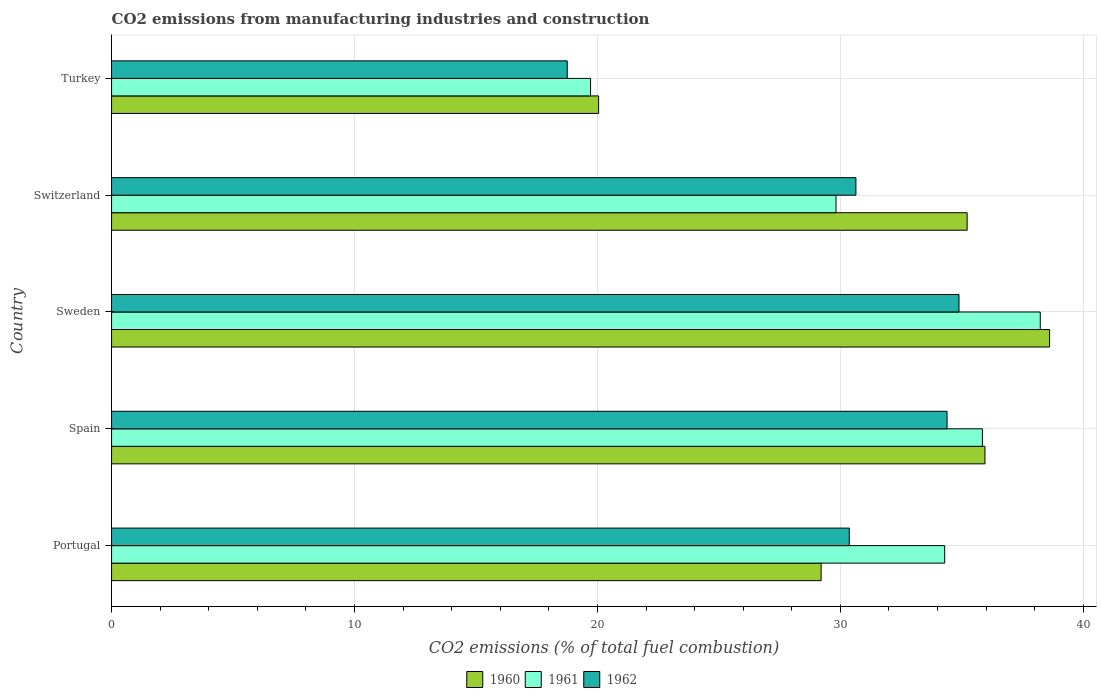Are the number of bars per tick equal to the number of legend labels?
Your answer should be very brief. Yes. Are the number of bars on each tick of the Y-axis equal?
Provide a succinct answer. Yes. In how many cases, is the number of bars for a given country not equal to the number of legend labels?
Ensure brevity in your answer.  0. What is the amount of CO2 emitted in 1960 in Spain?
Ensure brevity in your answer.  35.95. Across all countries, what is the maximum amount of CO2 emitted in 1960?
Keep it short and to the point. 38.61. Across all countries, what is the minimum amount of CO2 emitted in 1962?
Give a very brief answer. 18.76. In which country was the amount of CO2 emitted in 1962 minimum?
Ensure brevity in your answer.  Turkey. What is the total amount of CO2 emitted in 1961 in the graph?
Give a very brief answer. 157.91. What is the difference between the amount of CO2 emitted in 1961 in Portugal and that in Sweden?
Provide a succinct answer. -3.93. What is the difference between the amount of CO2 emitted in 1961 in Switzerland and the amount of CO2 emitted in 1962 in Portugal?
Make the answer very short. -0.55. What is the average amount of CO2 emitted in 1962 per country?
Ensure brevity in your answer.  29.81. What is the difference between the amount of CO2 emitted in 1960 and amount of CO2 emitted in 1961 in Sweden?
Keep it short and to the point. 0.38. What is the ratio of the amount of CO2 emitted in 1961 in Portugal to that in Spain?
Offer a very short reply. 0.96. Is the amount of CO2 emitted in 1960 in Sweden less than that in Switzerland?
Keep it short and to the point. No. Is the difference between the amount of CO2 emitted in 1960 in Spain and Turkey greater than the difference between the amount of CO2 emitted in 1961 in Spain and Turkey?
Give a very brief answer. No. What is the difference between the highest and the second highest amount of CO2 emitted in 1961?
Provide a succinct answer. 2.38. What is the difference between the highest and the lowest amount of CO2 emitted in 1962?
Offer a very short reply. 16.13. In how many countries, is the amount of CO2 emitted in 1962 greater than the average amount of CO2 emitted in 1962 taken over all countries?
Your answer should be very brief. 4. Is the sum of the amount of CO2 emitted in 1961 in Spain and Sweden greater than the maximum amount of CO2 emitted in 1962 across all countries?
Make the answer very short. Yes. What does the 2nd bar from the top in Switzerland represents?
Keep it short and to the point. 1961. Is it the case that in every country, the sum of the amount of CO2 emitted in 1961 and amount of CO2 emitted in 1960 is greater than the amount of CO2 emitted in 1962?
Offer a terse response. Yes. How many bars are there?
Provide a succinct answer. 15. Are all the bars in the graph horizontal?
Offer a very short reply. Yes. Does the graph contain any zero values?
Give a very brief answer. No. Does the graph contain grids?
Your response must be concise. Yes. How many legend labels are there?
Give a very brief answer. 3. What is the title of the graph?
Provide a succinct answer. CO2 emissions from manufacturing industries and construction. Does "2002" appear as one of the legend labels in the graph?
Your answer should be compact. No. What is the label or title of the X-axis?
Give a very brief answer. CO2 emissions (% of total fuel combustion). What is the CO2 emissions (% of total fuel combustion) in 1960 in Portugal?
Your answer should be compact. 29.21. What is the CO2 emissions (% of total fuel combustion) in 1961 in Portugal?
Give a very brief answer. 34.29. What is the CO2 emissions (% of total fuel combustion) in 1962 in Portugal?
Your answer should be compact. 30.37. What is the CO2 emissions (% of total fuel combustion) in 1960 in Spain?
Ensure brevity in your answer.  35.95. What is the CO2 emissions (% of total fuel combustion) of 1961 in Spain?
Your answer should be compact. 35.85. What is the CO2 emissions (% of total fuel combustion) in 1962 in Spain?
Give a very brief answer. 34.39. What is the CO2 emissions (% of total fuel combustion) of 1960 in Sweden?
Your answer should be very brief. 38.61. What is the CO2 emissions (% of total fuel combustion) in 1961 in Sweden?
Keep it short and to the point. 38.23. What is the CO2 emissions (% of total fuel combustion) of 1962 in Sweden?
Provide a short and direct response. 34.88. What is the CO2 emissions (% of total fuel combustion) of 1960 in Switzerland?
Your answer should be very brief. 35.22. What is the CO2 emissions (% of total fuel combustion) in 1961 in Switzerland?
Provide a short and direct response. 29.82. What is the CO2 emissions (% of total fuel combustion) in 1962 in Switzerland?
Provide a succinct answer. 30.64. What is the CO2 emissions (% of total fuel combustion) of 1960 in Turkey?
Ensure brevity in your answer.  20.05. What is the CO2 emissions (% of total fuel combustion) of 1961 in Turkey?
Your response must be concise. 19.72. What is the CO2 emissions (% of total fuel combustion) in 1962 in Turkey?
Your answer should be very brief. 18.76. Across all countries, what is the maximum CO2 emissions (% of total fuel combustion) of 1960?
Provide a short and direct response. 38.61. Across all countries, what is the maximum CO2 emissions (% of total fuel combustion) in 1961?
Make the answer very short. 38.23. Across all countries, what is the maximum CO2 emissions (% of total fuel combustion) in 1962?
Offer a very short reply. 34.88. Across all countries, what is the minimum CO2 emissions (% of total fuel combustion) in 1960?
Your response must be concise. 20.05. Across all countries, what is the minimum CO2 emissions (% of total fuel combustion) of 1961?
Offer a terse response. 19.72. Across all countries, what is the minimum CO2 emissions (% of total fuel combustion) in 1962?
Your answer should be compact. 18.76. What is the total CO2 emissions (% of total fuel combustion) in 1960 in the graph?
Provide a short and direct response. 159.04. What is the total CO2 emissions (% of total fuel combustion) in 1961 in the graph?
Make the answer very short. 157.91. What is the total CO2 emissions (% of total fuel combustion) of 1962 in the graph?
Your answer should be very brief. 149.04. What is the difference between the CO2 emissions (% of total fuel combustion) of 1960 in Portugal and that in Spain?
Your response must be concise. -6.74. What is the difference between the CO2 emissions (% of total fuel combustion) in 1961 in Portugal and that in Spain?
Ensure brevity in your answer.  -1.55. What is the difference between the CO2 emissions (% of total fuel combustion) of 1962 in Portugal and that in Spain?
Give a very brief answer. -4.03. What is the difference between the CO2 emissions (% of total fuel combustion) in 1960 in Portugal and that in Sweden?
Give a very brief answer. -9.4. What is the difference between the CO2 emissions (% of total fuel combustion) of 1961 in Portugal and that in Sweden?
Provide a succinct answer. -3.93. What is the difference between the CO2 emissions (% of total fuel combustion) of 1962 in Portugal and that in Sweden?
Provide a succinct answer. -4.52. What is the difference between the CO2 emissions (% of total fuel combustion) of 1960 in Portugal and that in Switzerland?
Provide a short and direct response. -6.01. What is the difference between the CO2 emissions (% of total fuel combustion) in 1961 in Portugal and that in Switzerland?
Your answer should be compact. 4.47. What is the difference between the CO2 emissions (% of total fuel combustion) of 1962 in Portugal and that in Switzerland?
Your response must be concise. -0.27. What is the difference between the CO2 emissions (% of total fuel combustion) in 1960 in Portugal and that in Turkey?
Give a very brief answer. 9.16. What is the difference between the CO2 emissions (% of total fuel combustion) of 1961 in Portugal and that in Turkey?
Offer a terse response. 14.58. What is the difference between the CO2 emissions (% of total fuel combustion) of 1962 in Portugal and that in Turkey?
Give a very brief answer. 11.61. What is the difference between the CO2 emissions (% of total fuel combustion) in 1960 in Spain and that in Sweden?
Ensure brevity in your answer.  -2.66. What is the difference between the CO2 emissions (% of total fuel combustion) in 1961 in Spain and that in Sweden?
Give a very brief answer. -2.38. What is the difference between the CO2 emissions (% of total fuel combustion) in 1962 in Spain and that in Sweden?
Offer a very short reply. -0.49. What is the difference between the CO2 emissions (% of total fuel combustion) of 1960 in Spain and that in Switzerland?
Offer a very short reply. 0.73. What is the difference between the CO2 emissions (% of total fuel combustion) in 1961 in Spain and that in Switzerland?
Your answer should be very brief. 6.03. What is the difference between the CO2 emissions (% of total fuel combustion) in 1962 in Spain and that in Switzerland?
Give a very brief answer. 3.75. What is the difference between the CO2 emissions (% of total fuel combustion) of 1960 in Spain and that in Turkey?
Your answer should be compact. 15.9. What is the difference between the CO2 emissions (% of total fuel combustion) in 1961 in Spain and that in Turkey?
Keep it short and to the point. 16.13. What is the difference between the CO2 emissions (% of total fuel combustion) of 1962 in Spain and that in Turkey?
Your response must be concise. 15.64. What is the difference between the CO2 emissions (% of total fuel combustion) in 1960 in Sweden and that in Switzerland?
Make the answer very short. 3.39. What is the difference between the CO2 emissions (% of total fuel combustion) in 1961 in Sweden and that in Switzerland?
Make the answer very short. 8.41. What is the difference between the CO2 emissions (% of total fuel combustion) of 1962 in Sweden and that in Switzerland?
Offer a very short reply. 4.24. What is the difference between the CO2 emissions (% of total fuel combustion) of 1960 in Sweden and that in Turkey?
Your response must be concise. 18.56. What is the difference between the CO2 emissions (% of total fuel combustion) in 1961 in Sweden and that in Turkey?
Ensure brevity in your answer.  18.51. What is the difference between the CO2 emissions (% of total fuel combustion) of 1962 in Sweden and that in Turkey?
Provide a short and direct response. 16.13. What is the difference between the CO2 emissions (% of total fuel combustion) in 1960 in Switzerland and that in Turkey?
Provide a succinct answer. 15.17. What is the difference between the CO2 emissions (% of total fuel combustion) in 1961 in Switzerland and that in Turkey?
Keep it short and to the point. 10.1. What is the difference between the CO2 emissions (% of total fuel combustion) in 1962 in Switzerland and that in Turkey?
Your answer should be very brief. 11.88. What is the difference between the CO2 emissions (% of total fuel combustion) of 1960 in Portugal and the CO2 emissions (% of total fuel combustion) of 1961 in Spain?
Offer a very short reply. -6.64. What is the difference between the CO2 emissions (% of total fuel combustion) in 1960 in Portugal and the CO2 emissions (% of total fuel combustion) in 1962 in Spain?
Keep it short and to the point. -5.18. What is the difference between the CO2 emissions (% of total fuel combustion) of 1961 in Portugal and the CO2 emissions (% of total fuel combustion) of 1962 in Spain?
Offer a very short reply. -0.1. What is the difference between the CO2 emissions (% of total fuel combustion) of 1960 in Portugal and the CO2 emissions (% of total fuel combustion) of 1961 in Sweden?
Provide a short and direct response. -9.02. What is the difference between the CO2 emissions (% of total fuel combustion) of 1960 in Portugal and the CO2 emissions (% of total fuel combustion) of 1962 in Sweden?
Provide a short and direct response. -5.68. What is the difference between the CO2 emissions (% of total fuel combustion) of 1961 in Portugal and the CO2 emissions (% of total fuel combustion) of 1962 in Sweden?
Provide a short and direct response. -0.59. What is the difference between the CO2 emissions (% of total fuel combustion) in 1960 in Portugal and the CO2 emissions (% of total fuel combustion) in 1961 in Switzerland?
Your response must be concise. -0.61. What is the difference between the CO2 emissions (% of total fuel combustion) in 1960 in Portugal and the CO2 emissions (% of total fuel combustion) in 1962 in Switzerland?
Make the answer very short. -1.43. What is the difference between the CO2 emissions (% of total fuel combustion) of 1961 in Portugal and the CO2 emissions (% of total fuel combustion) of 1962 in Switzerland?
Ensure brevity in your answer.  3.65. What is the difference between the CO2 emissions (% of total fuel combustion) of 1960 in Portugal and the CO2 emissions (% of total fuel combustion) of 1961 in Turkey?
Ensure brevity in your answer.  9.49. What is the difference between the CO2 emissions (% of total fuel combustion) in 1960 in Portugal and the CO2 emissions (% of total fuel combustion) in 1962 in Turkey?
Offer a terse response. 10.45. What is the difference between the CO2 emissions (% of total fuel combustion) in 1961 in Portugal and the CO2 emissions (% of total fuel combustion) in 1962 in Turkey?
Keep it short and to the point. 15.54. What is the difference between the CO2 emissions (% of total fuel combustion) of 1960 in Spain and the CO2 emissions (% of total fuel combustion) of 1961 in Sweden?
Provide a short and direct response. -2.28. What is the difference between the CO2 emissions (% of total fuel combustion) of 1960 in Spain and the CO2 emissions (% of total fuel combustion) of 1962 in Sweden?
Your response must be concise. 1.07. What is the difference between the CO2 emissions (% of total fuel combustion) of 1961 in Spain and the CO2 emissions (% of total fuel combustion) of 1962 in Sweden?
Your answer should be very brief. 0.96. What is the difference between the CO2 emissions (% of total fuel combustion) in 1960 in Spain and the CO2 emissions (% of total fuel combustion) in 1961 in Switzerland?
Keep it short and to the point. 6.13. What is the difference between the CO2 emissions (% of total fuel combustion) in 1960 in Spain and the CO2 emissions (% of total fuel combustion) in 1962 in Switzerland?
Offer a terse response. 5.31. What is the difference between the CO2 emissions (% of total fuel combustion) of 1961 in Spain and the CO2 emissions (% of total fuel combustion) of 1962 in Switzerland?
Offer a terse response. 5.21. What is the difference between the CO2 emissions (% of total fuel combustion) of 1960 in Spain and the CO2 emissions (% of total fuel combustion) of 1961 in Turkey?
Make the answer very short. 16.24. What is the difference between the CO2 emissions (% of total fuel combustion) in 1960 in Spain and the CO2 emissions (% of total fuel combustion) in 1962 in Turkey?
Provide a succinct answer. 17.2. What is the difference between the CO2 emissions (% of total fuel combustion) of 1961 in Spain and the CO2 emissions (% of total fuel combustion) of 1962 in Turkey?
Keep it short and to the point. 17.09. What is the difference between the CO2 emissions (% of total fuel combustion) in 1960 in Sweden and the CO2 emissions (% of total fuel combustion) in 1961 in Switzerland?
Offer a very short reply. 8.79. What is the difference between the CO2 emissions (% of total fuel combustion) of 1960 in Sweden and the CO2 emissions (% of total fuel combustion) of 1962 in Switzerland?
Your answer should be compact. 7.97. What is the difference between the CO2 emissions (% of total fuel combustion) of 1961 in Sweden and the CO2 emissions (% of total fuel combustion) of 1962 in Switzerland?
Offer a very short reply. 7.59. What is the difference between the CO2 emissions (% of total fuel combustion) in 1960 in Sweden and the CO2 emissions (% of total fuel combustion) in 1961 in Turkey?
Provide a succinct answer. 18.9. What is the difference between the CO2 emissions (% of total fuel combustion) of 1960 in Sweden and the CO2 emissions (% of total fuel combustion) of 1962 in Turkey?
Offer a very short reply. 19.86. What is the difference between the CO2 emissions (% of total fuel combustion) in 1961 in Sweden and the CO2 emissions (% of total fuel combustion) in 1962 in Turkey?
Provide a succinct answer. 19.47. What is the difference between the CO2 emissions (% of total fuel combustion) of 1960 in Switzerland and the CO2 emissions (% of total fuel combustion) of 1961 in Turkey?
Your answer should be very brief. 15.5. What is the difference between the CO2 emissions (% of total fuel combustion) of 1960 in Switzerland and the CO2 emissions (% of total fuel combustion) of 1962 in Turkey?
Offer a terse response. 16.46. What is the difference between the CO2 emissions (% of total fuel combustion) in 1961 in Switzerland and the CO2 emissions (% of total fuel combustion) in 1962 in Turkey?
Provide a short and direct response. 11.06. What is the average CO2 emissions (% of total fuel combustion) of 1960 per country?
Offer a very short reply. 31.81. What is the average CO2 emissions (% of total fuel combustion) of 1961 per country?
Your response must be concise. 31.58. What is the average CO2 emissions (% of total fuel combustion) in 1962 per country?
Your answer should be very brief. 29.81. What is the difference between the CO2 emissions (% of total fuel combustion) of 1960 and CO2 emissions (% of total fuel combustion) of 1961 in Portugal?
Offer a terse response. -5.09. What is the difference between the CO2 emissions (% of total fuel combustion) of 1960 and CO2 emissions (% of total fuel combustion) of 1962 in Portugal?
Your answer should be compact. -1.16. What is the difference between the CO2 emissions (% of total fuel combustion) of 1961 and CO2 emissions (% of total fuel combustion) of 1962 in Portugal?
Your answer should be very brief. 3.93. What is the difference between the CO2 emissions (% of total fuel combustion) in 1960 and CO2 emissions (% of total fuel combustion) in 1961 in Spain?
Your response must be concise. 0.1. What is the difference between the CO2 emissions (% of total fuel combustion) of 1960 and CO2 emissions (% of total fuel combustion) of 1962 in Spain?
Offer a terse response. 1.56. What is the difference between the CO2 emissions (% of total fuel combustion) of 1961 and CO2 emissions (% of total fuel combustion) of 1962 in Spain?
Your answer should be very brief. 1.45. What is the difference between the CO2 emissions (% of total fuel combustion) in 1960 and CO2 emissions (% of total fuel combustion) in 1961 in Sweden?
Provide a short and direct response. 0.38. What is the difference between the CO2 emissions (% of total fuel combustion) of 1960 and CO2 emissions (% of total fuel combustion) of 1962 in Sweden?
Offer a very short reply. 3.73. What is the difference between the CO2 emissions (% of total fuel combustion) in 1961 and CO2 emissions (% of total fuel combustion) in 1962 in Sweden?
Ensure brevity in your answer.  3.35. What is the difference between the CO2 emissions (% of total fuel combustion) in 1960 and CO2 emissions (% of total fuel combustion) in 1961 in Switzerland?
Your response must be concise. 5.4. What is the difference between the CO2 emissions (% of total fuel combustion) of 1960 and CO2 emissions (% of total fuel combustion) of 1962 in Switzerland?
Provide a succinct answer. 4.58. What is the difference between the CO2 emissions (% of total fuel combustion) of 1961 and CO2 emissions (% of total fuel combustion) of 1962 in Switzerland?
Offer a very short reply. -0.82. What is the difference between the CO2 emissions (% of total fuel combustion) in 1960 and CO2 emissions (% of total fuel combustion) in 1961 in Turkey?
Provide a short and direct response. 0.33. What is the difference between the CO2 emissions (% of total fuel combustion) in 1960 and CO2 emissions (% of total fuel combustion) in 1962 in Turkey?
Keep it short and to the point. 1.29. What is the difference between the CO2 emissions (% of total fuel combustion) of 1961 and CO2 emissions (% of total fuel combustion) of 1962 in Turkey?
Give a very brief answer. 0.96. What is the ratio of the CO2 emissions (% of total fuel combustion) of 1960 in Portugal to that in Spain?
Make the answer very short. 0.81. What is the ratio of the CO2 emissions (% of total fuel combustion) in 1961 in Portugal to that in Spain?
Provide a succinct answer. 0.96. What is the ratio of the CO2 emissions (% of total fuel combustion) of 1962 in Portugal to that in Spain?
Ensure brevity in your answer.  0.88. What is the ratio of the CO2 emissions (% of total fuel combustion) of 1960 in Portugal to that in Sweden?
Keep it short and to the point. 0.76. What is the ratio of the CO2 emissions (% of total fuel combustion) of 1961 in Portugal to that in Sweden?
Your answer should be very brief. 0.9. What is the ratio of the CO2 emissions (% of total fuel combustion) of 1962 in Portugal to that in Sweden?
Your answer should be compact. 0.87. What is the ratio of the CO2 emissions (% of total fuel combustion) of 1960 in Portugal to that in Switzerland?
Provide a succinct answer. 0.83. What is the ratio of the CO2 emissions (% of total fuel combustion) in 1961 in Portugal to that in Switzerland?
Offer a terse response. 1.15. What is the ratio of the CO2 emissions (% of total fuel combustion) in 1962 in Portugal to that in Switzerland?
Provide a succinct answer. 0.99. What is the ratio of the CO2 emissions (% of total fuel combustion) in 1960 in Portugal to that in Turkey?
Make the answer very short. 1.46. What is the ratio of the CO2 emissions (% of total fuel combustion) in 1961 in Portugal to that in Turkey?
Give a very brief answer. 1.74. What is the ratio of the CO2 emissions (% of total fuel combustion) of 1962 in Portugal to that in Turkey?
Offer a terse response. 1.62. What is the ratio of the CO2 emissions (% of total fuel combustion) in 1960 in Spain to that in Sweden?
Make the answer very short. 0.93. What is the ratio of the CO2 emissions (% of total fuel combustion) of 1961 in Spain to that in Sweden?
Give a very brief answer. 0.94. What is the ratio of the CO2 emissions (% of total fuel combustion) in 1962 in Spain to that in Sweden?
Ensure brevity in your answer.  0.99. What is the ratio of the CO2 emissions (% of total fuel combustion) in 1960 in Spain to that in Switzerland?
Ensure brevity in your answer.  1.02. What is the ratio of the CO2 emissions (% of total fuel combustion) in 1961 in Spain to that in Switzerland?
Offer a very short reply. 1.2. What is the ratio of the CO2 emissions (% of total fuel combustion) of 1962 in Spain to that in Switzerland?
Your answer should be very brief. 1.12. What is the ratio of the CO2 emissions (% of total fuel combustion) of 1960 in Spain to that in Turkey?
Provide a succinct answer. 1.79. What is the ratio of the CO2 emissions (% of total fuel combustion) of 1961 in Spain to that in Turkey?
Your answer should be compact. 1.82. What is the ratio of the CO2 emissions (% of total fuel combustion) of 1962 in Spain to that in Turkey?
Provide a succinct answer. 1.83. What is the ratio of the CO2 emissions (% of total fuel combustion) of 1960 in Sweden to that in Switzerland?
Make the answer very short. 1.1. What is the ratio of the CO2 emissions (% of total fuel combustion) of 1961 in Sweden to that in Switzerland?
Provide a short and direct response. 1.28. What is the ratio of the CO2 emissions (% of total fuel combustion) in 1962 in Sweden to that in Switzerland?
Your answer should be compact. 1.14. What is the ratio of the CO2 emissions (% of total fuel combustion) of 1960 in Sweden to that in Turkey?
Provide a succinct answer. 1.93. What is the ratio of the CO2 emissions (% of total fuel combustion) of 1961 in Sweden to that in Turkey?
Offer a terse response. 1.94. What is the ratio of the CO2 emissions (% of total fuel combustion) in 1962 in Sweden to that in Turkey?
Offer a very short reply. 1.86. What is the ratio of the CO2 emissions (% of total fuel combustion) in 1960 in Switzerland to that in Turkey?
Offer a very short reply. 1.76. What is the ratio of the CO2 emissions (% of total fuel combustion) of 1961 in Switzerland to that in Turkey?
Provide a short and direct response. 1.51. What is the ratio of the CO2 emissions (% of total fuel combustion) in 1962 in Switzerland to that in Turkey?
Offer a very short reply. 1.63. What is the difference between the highest and the second highest CO2 emissions (% of total fuel combustion) in 1960?
Your response must be concise. 2.66. What is the difference between the highest and the second highest CO2 emissions (% of total fuel combustion) of 1961?
Your answer should be very brief. 2.38. What is the difference between the highest and the second highest CO2 emissions (% of total fuel combustion) in 1962?
Offer a terse response. 0.49. What is the difference between the highest and the lowest CO2 emissions (% of total fuel combustion) of 1960?
Provide a succinct answer. 18.56. What is the difference between the highest and the lowest CO2 emissions (% of total fuel combustion) in 1961?
Ensure brevity in your answer.  18.51. What is the difference between the highest and the lowest CO2 emissions (% of total fuel combustion) in 1962?
Offer a very short reply. 16.13. 